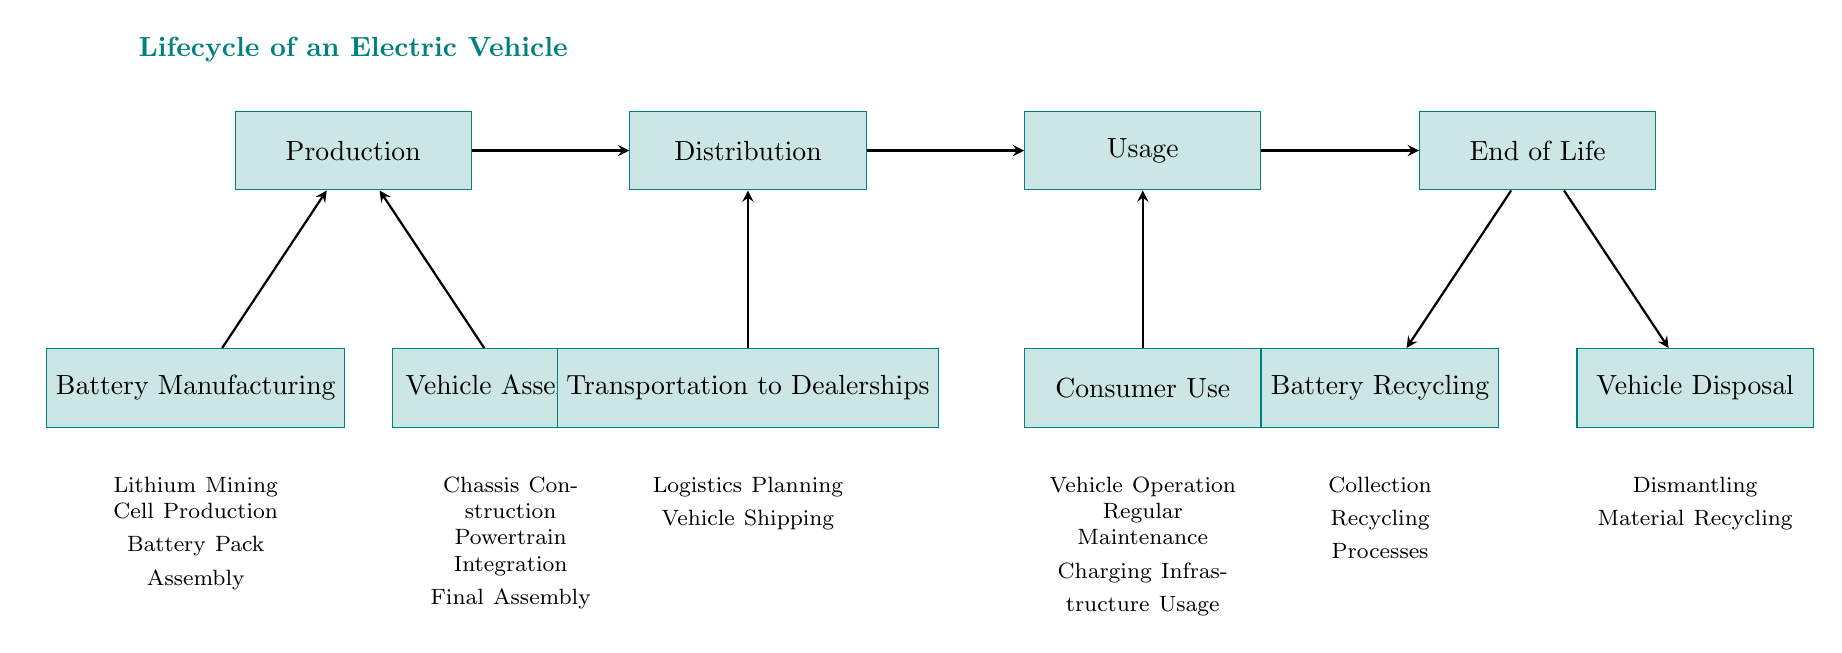What are the major phases in the lifecycle of an electric vehicle? The diagram shows four major phases: Production, Distribution, Usage, and End of Life. These phases are sequentially connected, indicating the flow of the lifecycle.
Answer: Production, Distribution, Usage, End of Life How many processes are involved in Production? Under the Production phase, there are two main processes listed: Battery Manufacturing and Vehicle Assembly. Each of these processes has further details. Thus, there are two primary processes in Production.
Answer: 2 What process occurs after Distribution? The flow of the diagram indicates that the process following Distribution is Usage. The arrows demonstrate the direction of the lifecycle progression.
Answer: Usage What is one of the activities involved in Battery Recycling? The diagram shows that Battery Recycling includes processes like Collection and Recycling Processes. Thus, one specific activity mentioned is Collection.
Answer: Collection How many specific tasks are listed under Vehicle Assembly? The Vehicle Assembly process has three specific tasks mentioned below it: Chassis Construction, Powertrain Integration, and Final Assembly. Therefore, there are three tasks in this category.
Answer: 3 Which process comes after Consumer Use? Following the Consumer Use phase, the diagram flows into the End of Life phase. This indicates the lifecycle transition that occurs after the usage of the vehicle.
Answer: End of Life What are the two types of processes involved in End of Life? The End of Life phase includes two distinct processes: Battery Recycling and Vehicle Disposal, as shown in the diagram. Each process has further activities outlined.
Answer: Battery Recycling, Vehicle Disposal How does a vehicle reach Distribution from Production? The diagram shows a direct arrow from Production to Distribution, indicating a unidirectional flow that signifies the transition of a vehicle from being produced to being distributed.
Answer: Through a direct flow/arrow What are the two processes involved in Transportation to Dealerships? The Transportation to Dealerships process consists of Logistics Planning and Vehicle Shipping, both listed under this node in the diagram.
Answer: Logistics Planning, Vehicle Shipping 